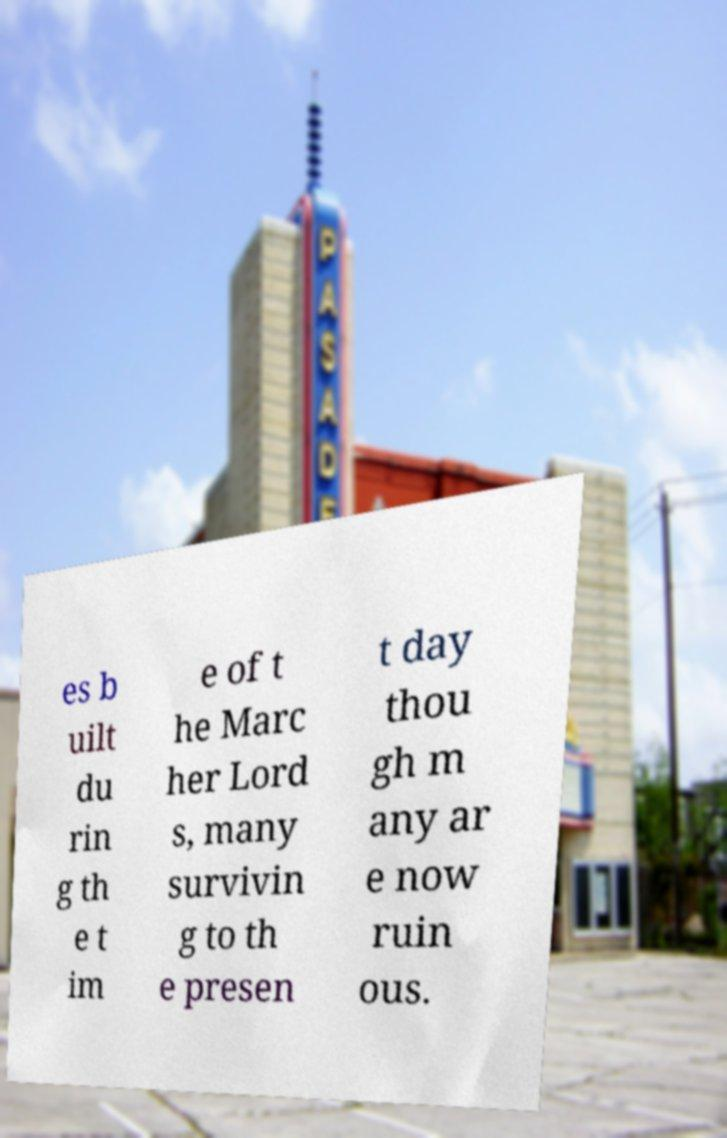Can you accurately transcribe the text from the provided image for me? es b uilt du rin g th e t im e of t he Marc her Lord s, many survivin g to th e presen t day thou gh m any ar e now ruin ous. 